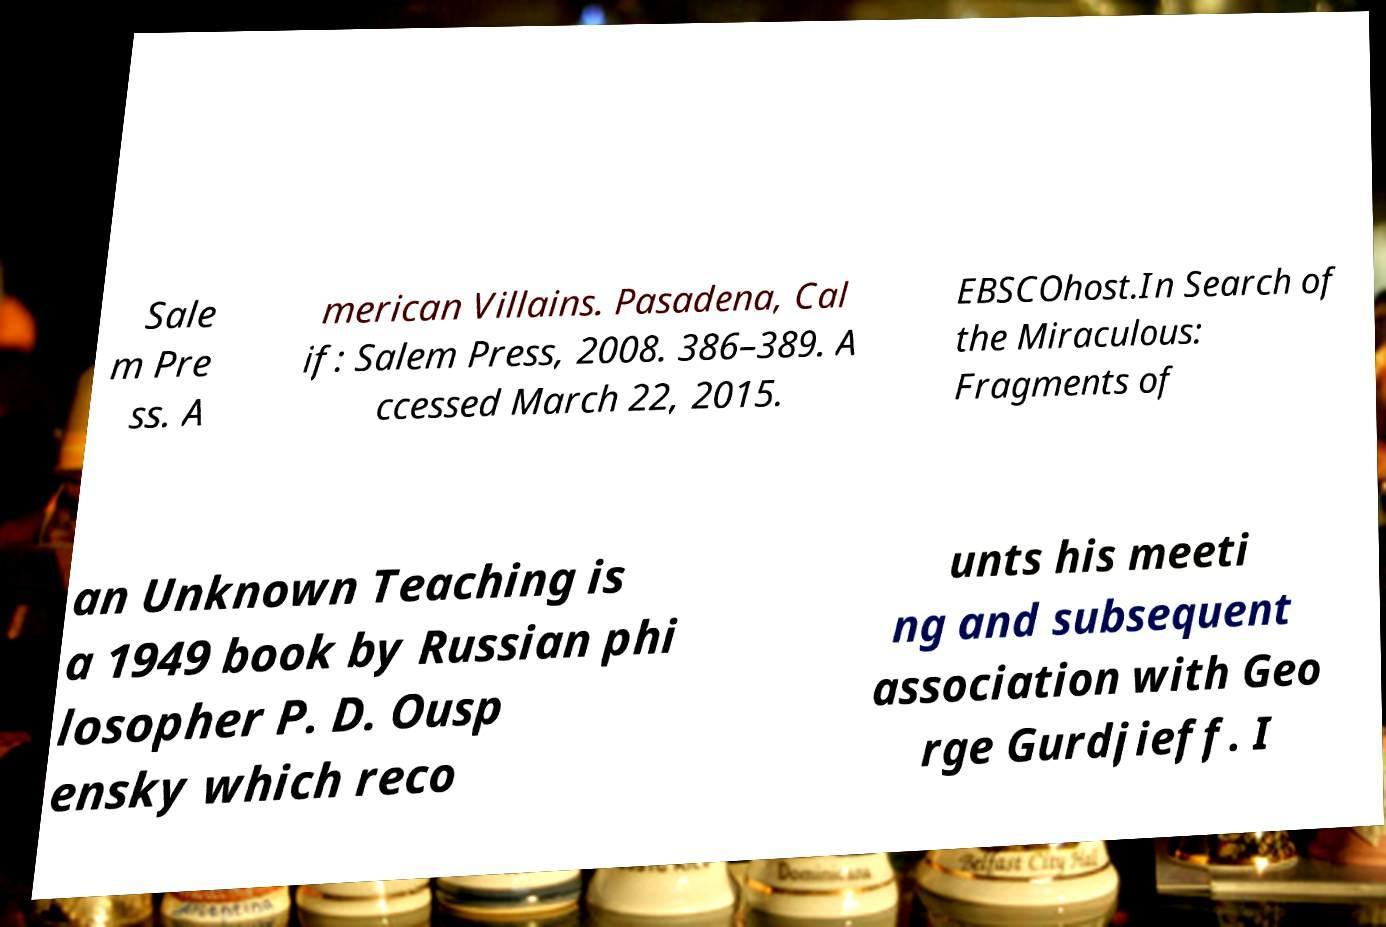Please identify and transcribe the text found in this image. Sale m Pre ss. A merican Villains. Pasadena, Cal if: Salem Press, 2008. 386–389. A ccessed March 22, 2015. EBSCOhost.In Search of the Miraculous: Fragments of an Unknown Teaching is a 1949 book by Russian phi losopher P. D. Ousp ensky which reco unts his meeti ng and subsequent association with Geo rge Gurdjieff. I 